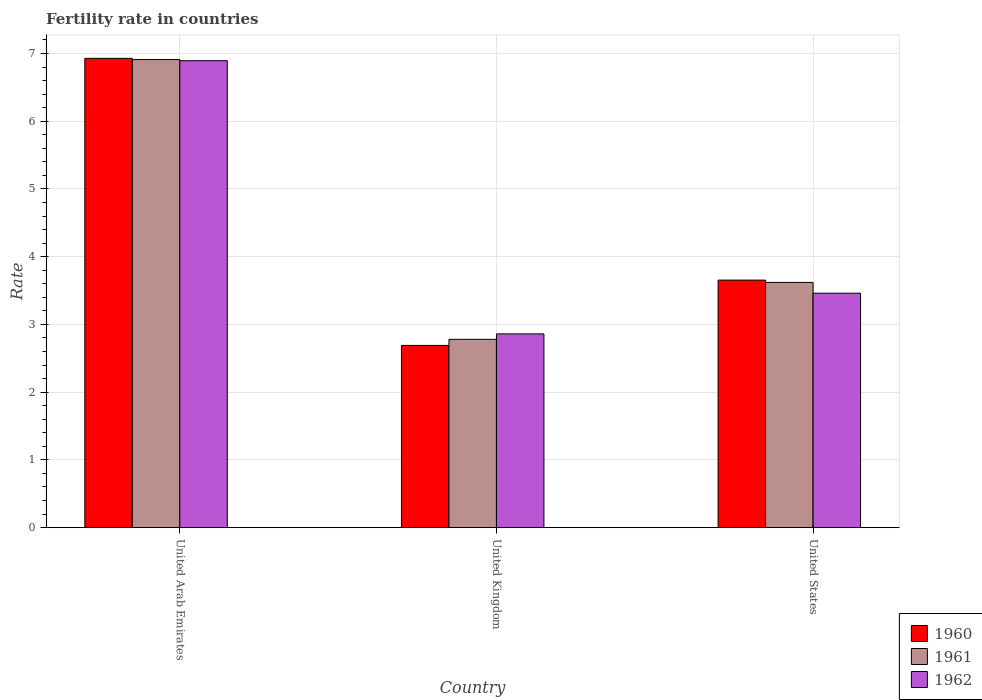How many different coloured bars are there?
Make the answer very short. 3. Are the number of bars per tick equal to the number of legend labels?
Give a very brief answer. Yes. Are the number of bars on each tick of the X-axis equal?
Provide a short and direct response. Yes. How many bars are there on the 2nd tick from the right?
Provide a short and direct response. 3. What is the label of the 1st group of bars from the left?
Your answer should be very brief. United Arab Emirates. What is the fertility rate in 1961 in United Arab Emirates?
Give a very brief answer. 6.91. Across all countries, what is the maximum fertility rate in 1962?
Provide a short and direct response. 6.89. Across all countries, what is the minimum fertility rate in 1961?
Your response must be concise. 2.78. In which country was the fertility rate in 1961 maximum?
Your answer should be compact. United Arab Emirates. What is the total fertility rate in 1962 in the graph?
Provide a succinct answer. 13.21. What is the difference between the fertility rate in 1961 in United Arab Emirates and that in United States?
Offer a very short reply. 3.29. What is the difference between the fertility rate in 1960 in United Kingdom and the fertility rate in 1961 in United States?
Offer a terse response. -0.93. What is the average fertility rate in 1962 per country?
Your response must be concise. 4.4. What is the difference between the fertility rate of/in 1960 and fertility rate of/in 1961 in United Kingdom?
Provide a succinct answer. -0.09. What is the ratio of the fertility rate in 1962 in United Kingdom to that in United States?
Offer a very short reply. 0.83. What is the difference between the highest and the second highest fertility rate in 1960?
Your answer should be very brief. -0.96. What is the difference between the highest and the lowest fertility rate in 1960?
Your answer should be very brief. 4.24. Is the sum of the fertility rate in 1961 in United Arab Emirates and United Kingdom greater than the maximum fertility rate in 1962 across all countries?
Provide a succinct answer. Yes. What does the 2nd bar from the right in United States represents?
Your response must be concise. 1961. Are all the bars in the graph horizontal?
Your answer should be compact. No. How many countries are there in the graph?
Offer a very short reply. 3. Are the values on the major ticks of Y-axis written in scientific E-notation?
Provide a short and direct response. No. Does the graph contain any zero values?
Make the answer very short. No. Does the graph contain grids?
Your response must be concise. Yes. How many legend labels are there?
Keep it short and to the point. 3. What is the title of the graph?
Your response must be concise. Fertility rate in countries. What is the label or title of the X-axis?
Offer a very short reply. Country. What is the label or title of the Y-axis?
Your answer should be very brief. Rate. What is the Rate in 1960 in United Arab Emirates?
Your answer should be compact. 6.93. What is the Rate of 1961 in United Arab Emirates?
Offer a terse response. 6.91. What is the Rate in 1962 in United Arab Emirates?
Offer a terse response. 6.89. What is the Rate in 1960 in United Kingdom?
Offer a terse response. 2.69. What is the Rate of 1961 in United Kingdom?
Your response must be concise. 2.78. What is the Rate of 1962 in United Kingdom?
Your response must be concise. 2.86. What is the Rate in 1960 in United States?
Offer a terse response. 3.65. What is the Rate of 1961 in United States?
Offer a terse response. 3.62. What is the Rate in 1962 in United States?
Keep it short and to the point. 3.46. Across all countries, what is the maximum Rate of 1960?
Ensure brevity in your answer.  6.93. Across all countries, what is the maximum Rate of 1961?
Make the answer very short. 6.91. Across all countries, what is the maximum Rate in 1962?
Give a very brief answer. 6.89. Across all countries, what is the minimum Rate in 1960?
Provide a short and direct response. 2.69. Across all countries, what is the minimum Rate in 1961?
Make the answer very short. 2.78. Across all countries, what is the minimum Rate of 1962?
Provide a succinct answer. 2.86. What is the total Rate of 1960 in the graph?
Your answer should be very brief. 13.27. What is the total Rate in 1961 in the graph?
Your answer should be compact. 13.31. What is the total Rate of 1962 in the graph?
Give a very brief answer. 13.21. What is the difference between the Rate in 1960 in United Arab Emirates and that in United Kingdom?
Provide a short and direct response. 4.24. What is the difference between the Rate in 1961 in United Arab Emirates and that in United Kingdom?
Provide a short and direct response. 4.13. What is the difference between the Rate in 1962 in United Arab Emirates and that in United Kingdom?
Make the answer very short. 4.03. What is the difference between the Rate of 1960 in United Arab Emirates and that in United States?
Your answer should be compact. 3.27. What is the difference between the Rate of 1961 in United Arab Emirates and that in United States?
Provide a succinct answer. 3.29. What is the difference between the Rate in 1962 in United Arab Emirates and that in United States?
Make the answer very short. 3.43. What is the difference between the Rate of 1960 in United Kingdom and that in United States?
Keep it short and to the point. -0.96. What is the difference between the Rate of 1961 in United Kingdom and that in United States?
Your response must be concise. -0.84. What is the difference between the Rate of 1962 in United Kingdom and that in United States?
Your answer should be compact. -0.6. What is the difference between the Rate of 1960 in United Arab Emirates and the Rate of 1961 in United Kingdom?
Offer a terse response. 4.15. What is the difference between the Rate in 1960 in United Arab Emirates and the Rate in 1962 in United Kingdom?
Provide a succinct answer. 4.07. What is the difference between the Rate of 1961 in United Arab Emirates and the Rate of 1962 in United Kingdom?
Keep it short and to the point. 4.05. What is the difference between the Rate of 1960 in United Arab Emirates and the Rate of 1961 in United States?
Provide a succinct answer. 3.31. What is the difference between the Rate in 1960 in United Arab Emirates and the Rate in 1962 in United States?
Your answer should be very brief. 3.47. What is the difference between the Rate in 1961 in United Arab Emirates and the Rate in 1962 in United States?
Your answer should be compact. 3.45. What is the difference between the Rate of 1960 in United Kingdom and the Rate of 1961 in United States?
Give a very brief answer. -0.93. What is the difference between the Rate of 1960 in United Kingdom and the Rate of 1962 in United States?
Provide a short and direct response. -0.77. What is the difference between the Rate in 1961 in United Kingdom and the Rate in 1962 in United States?
Offer a very short reply. -0.68. What is the average Rate of 1960 per country?
Offer a very short reply. 4.42. What is the average Rate of 1961 per country?
Your response must be concise. 4.44. What is the average Rate in 1962 per country?
Your answer should be compact. 4.4. What is the difference between the Rate in 1960 and Rate in 1961 in United Arab Emirates?
Your answer should be very brief. 0.02. What is the difference between the Rate in 1960 and Rate in 1962 in United Arab Emirates?
Make the answer very short. 0.04. What is the difference between the Rate of 1961 and Rate of 1962 in United Arab Emirates?
Your response must be concise. 0.02. What is the difference between the Rate in 1960 and Rate in 1961 in United Kingdom?
Ensure brevity in your answer.  -0.09. What is the difference between the Rate of 1960 and Rate of 1962 in United Kingdom?
Your response must be concise. -0.17. What is the difference between the Rate in 1961 and Rate in 1962 in United Kingdom?
Make the answer very short. -0.08. What is the difference between the Rate of 1960 and Rate of 1961 in United States?
Provide a succinct answer. 0.03. What is the difference between the Rate in 1960 and Rate in 1962 in United States?
Your answer should be compact. 0.19. What is the difference between the Rate in 1961 and Rate in 1962 in United States?
Provide a succinct answer. 0.16. What is the ratio of the Rate in 1960 in United Arab Emirates to that in United Kingdom?
Offer a terse response. 2.58. What is the ratio of the Rate of 1961 in United Arab Emirates to that in United Kingdom?
Give a very brief answer. 2.49. What is the ratio of the Rate in 1962 in United Arab Emirates to that in United Kingdom?
Provide a succinct answer. 2.41. What is the ratio of the Rate of 1960 in United Arab Emirates to that in United States?
Your response must be concise. 1.9. What is the ratio of the Rate in 1961 in United Arab Emirates to that in United States?
Give a very brief answer. 1.91. What is the ratio of the Rate in 1962 in United Arab Emirates to that in United States?
Your response must be concise. 1.99. What is the ratio of the Rate in 1960 in United Kingdom to that in United States?
Make the answer very short. 0.74. What is the ratio of the Rate in 1961 in United Kingdom to that in United States?
Provide a short and direct response. 0.77. What is the ratio of the Rate in 1962 in United Kingdom to that in United States?
Ensure brevity in your answer.  0.83. What is the difference between the highest and the second highest Rate of 1960?
Your answer should be very brief. 3.27. What is the difference between the highest and the second highest Rate in 1961?
Give a very brief answer. 3.29. What is the difference between the highest and the second highest Rate of 1962?
Offer a very short reply. 3.43. What is the difference between the highest and the lowest Rate of 1960?
Provide a short and direct response. 4.24. What is the difference between the highest and the lowest Rate of 1961?
Offer a terse response. 4.13. What is the difference between the highest and the lowest Rate of 1962?
Offer a terse response. 4.03. 